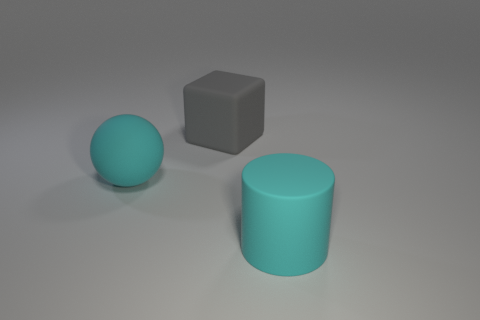Add 2 brown spheres. How many objects exist? 5 Subtract all cylinders. How many objects are left? 2 Subtract all yellow cylinders. Subtract all green cubes. How many cylinders are left? 1 Subtract all rubber spheres. Subtract all green matte cubes. How many objects are left? 2 Add 1 large gray matte blocks. How many large gray matte blocks are left? 2 Add 1 red rubber spheres. How many red rubber spheres exist? 1 Subtract 0 brown balls. How many objects are left? 3 